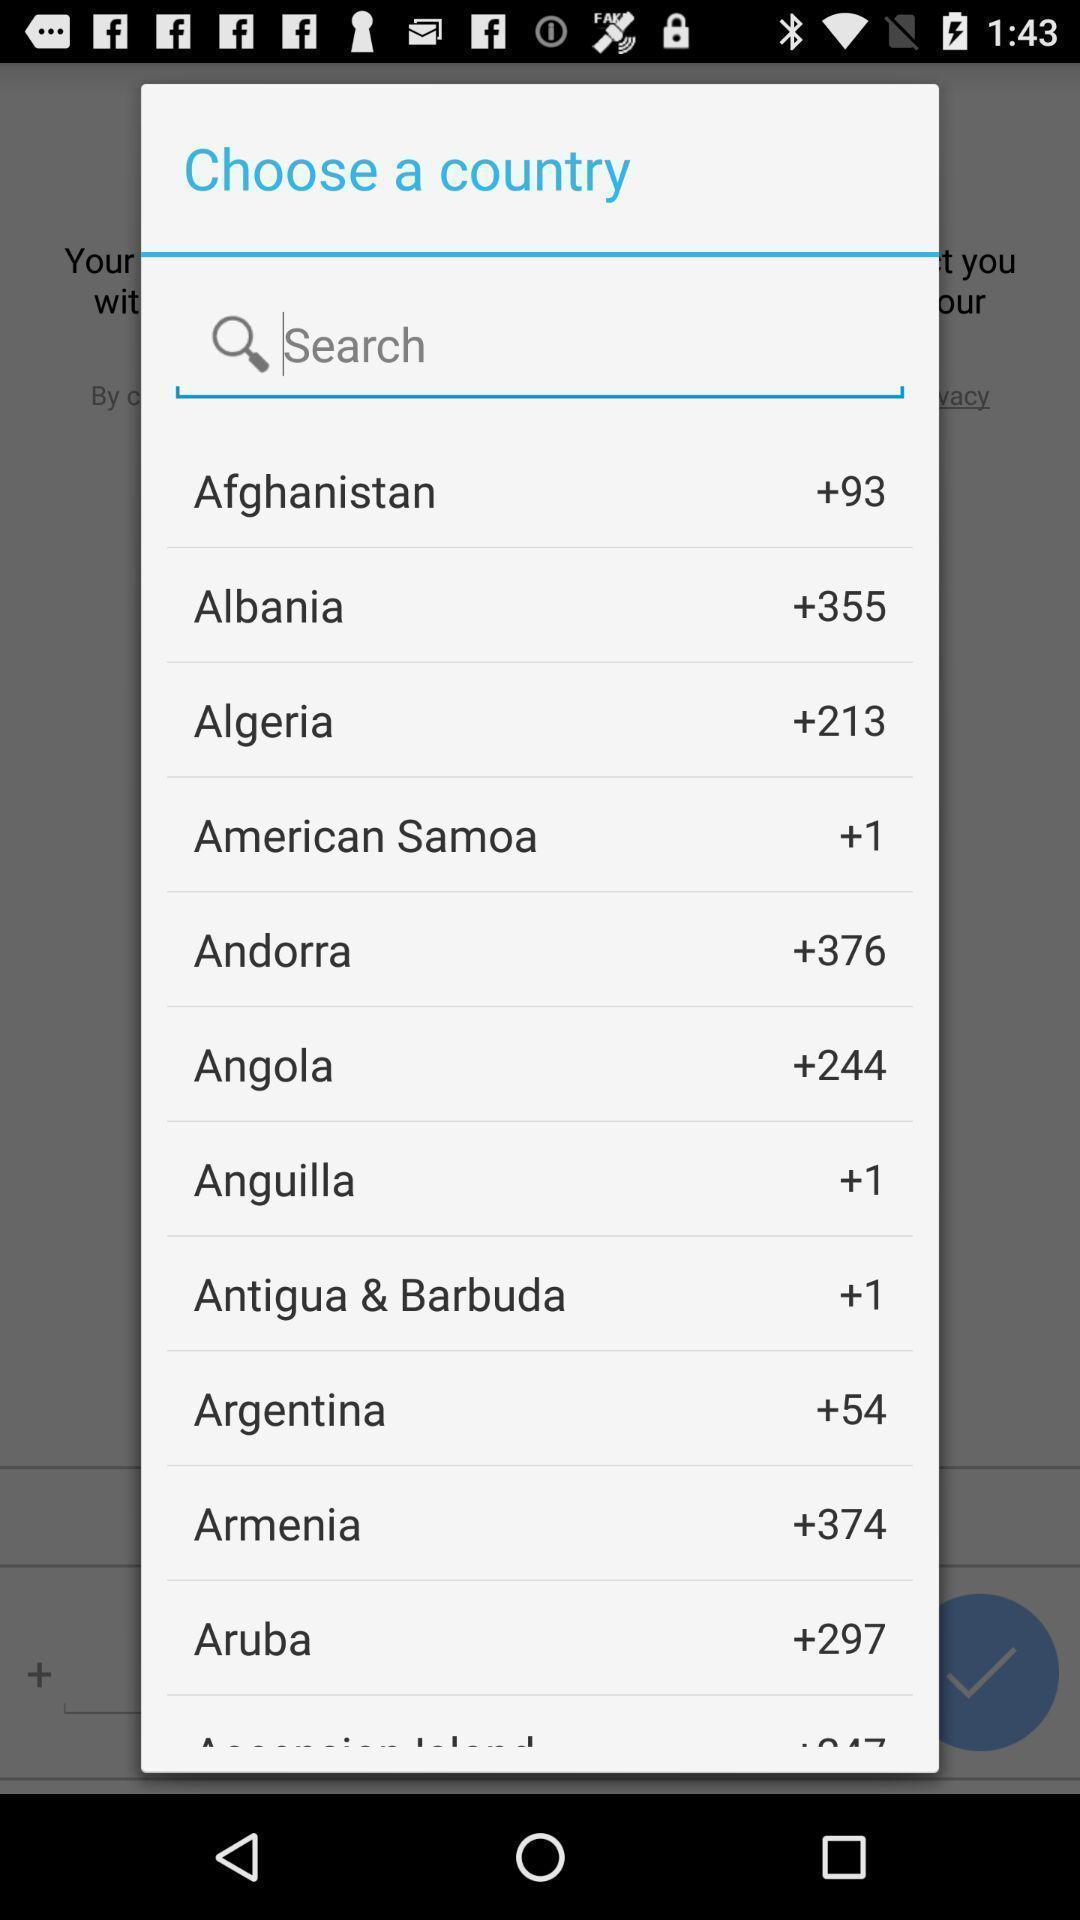Describe the content in this image. Pop up window with countries and codes. 